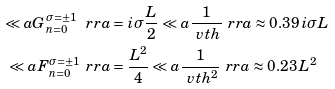<formula> <loc_0><loc_0><loc_500><loc_500>\ll a G _ { n = 0 } ^ { \sigma = \pm 1 } \ r r a & = i \sigma \frac { L } { 2 } \ll a \frac { 1 } { \ v t h } \ r r a \approx 0 . 3 9 \, i \sigma L \\ \ll a F _ { n = 0 } ^ { \sigma = \pm 1 } \ r r a & = \frac { L ^ { 2 } } { 4 } \ll a \frac { 1 } { \ v t h ^ { 2 } } \ r r a \approx 0 . 2 3 \, L ^ { 2 }</formula> 